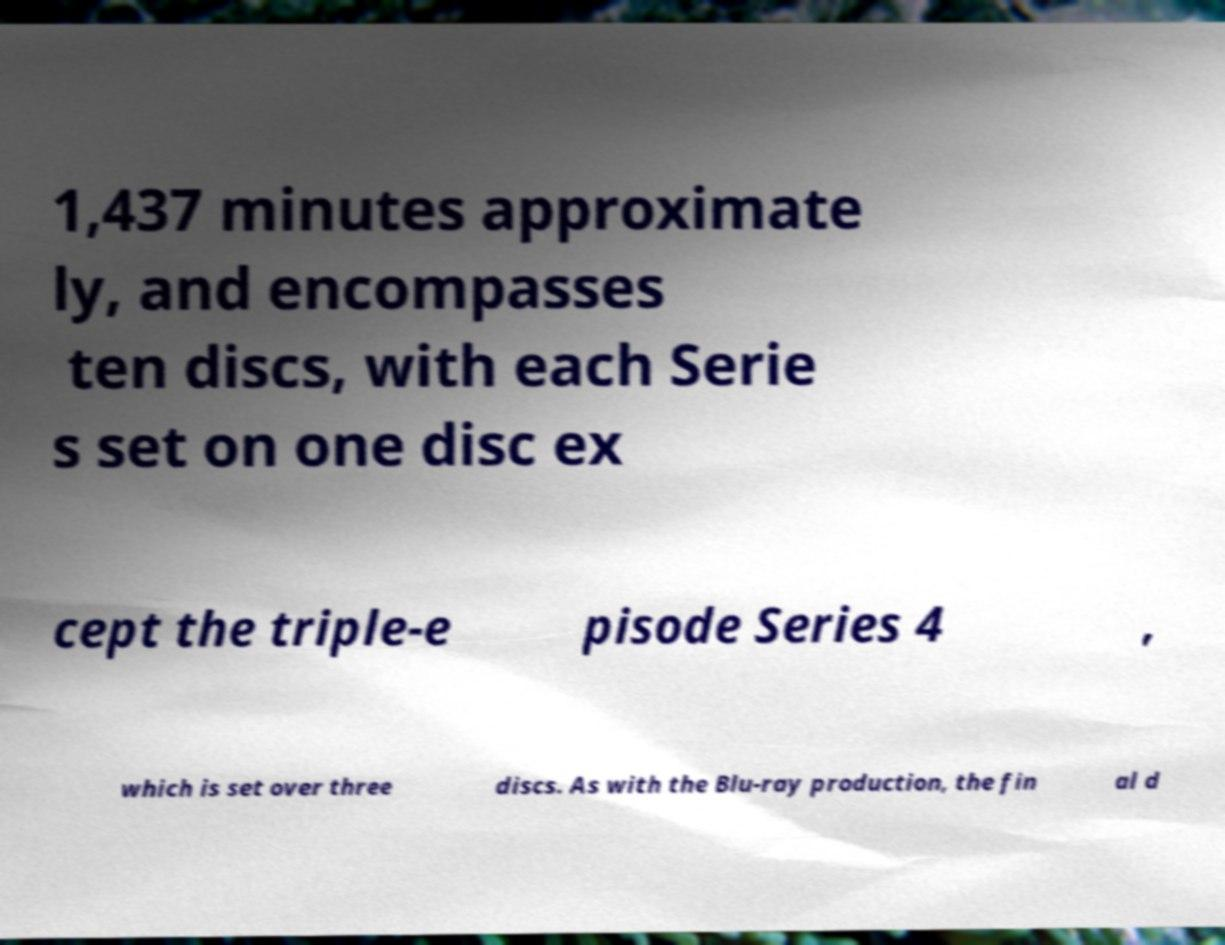For documentation purposes, I need the text within this image transcribed. Could you provide that? 1,437 minutes approximate ly, and encompasses ten discs, with each Serie s set on one disc ex cept the triple-e pisode Series 4 , which is set over three discs. As with the Blu-ray production, the fin al d 